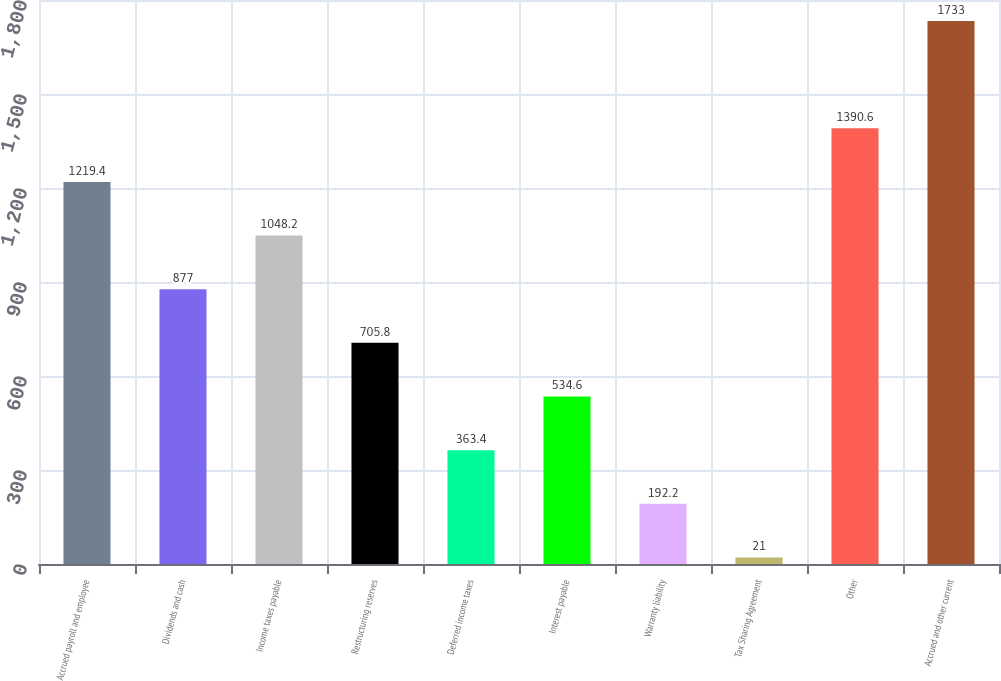Convert chart to OTSL. <chart><loc_0><loc_0><loc_500><loc_500><bar_chart><fcel>Accrued payroll and employee<fcel>Dividends and cash<fcel>Income taxes payable<fcel>Restructuring reserves<fcel>Deferred income taxes<fcel>Interest payable<fcel>Warranty liability<fcel>Tax Sharing Agreement<fcel>Other<fcel>Accrued and other current<nl><fcel>1219.4<fcel>877<fcel>1048.2<fcel>705.8<fcel>363.4<fcel>534.6<fcel>192.2<fcel>21<fcel>1390.6<fcel>1733<nl></chart> 